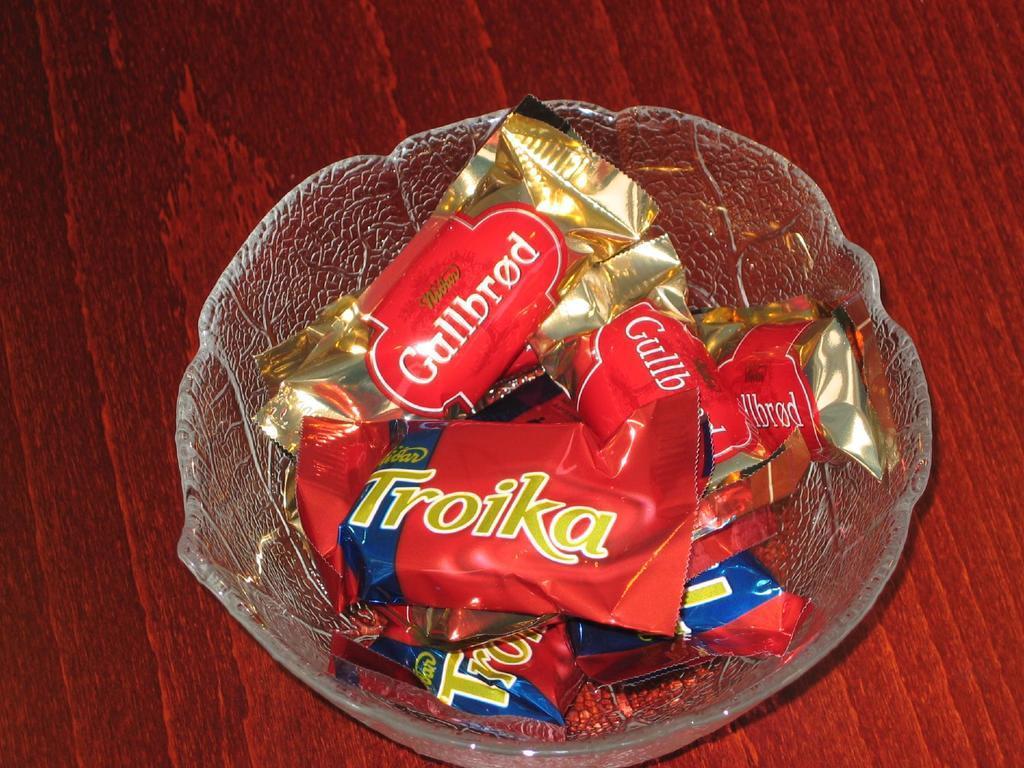Describe this image in one or two sentences. In this image in the center there is one bowl and in that bowl there are some chocolates, at the bottom there is a table. 